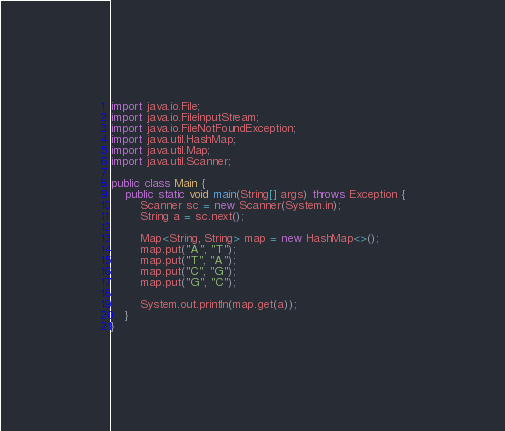Convert code to text. <code><loc_0><loc_0><loc_500><loc_500><_Java_>import java.io.File;
import java.io.FileInputStream;
import java.io.FileNotFoundException;
import java.util.HashMap;
import java.util.Map;
import java.util.Scanner;

public class Main {
    public static void main(String[] args) throws Exception {
        Scanner sc = new Scanner(System.in);
        String a = sc.next();

        Map<String, String> map = new HashMap<>();
        map.put("A", "T");
        map.put("T", "A");
        map.put("C", "G");
        map.put("G", "C");

        System.out.println(map.get(a));
    }
}
</code> 